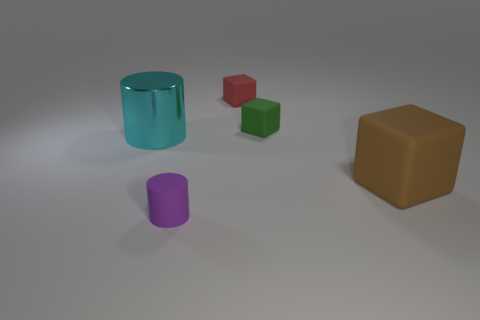What is the relative size of the cyan cylinder compared to the purple one? The cyan cylinder is significantly larger than the purple one, both in height and diameter, implying it has a greater volume. 